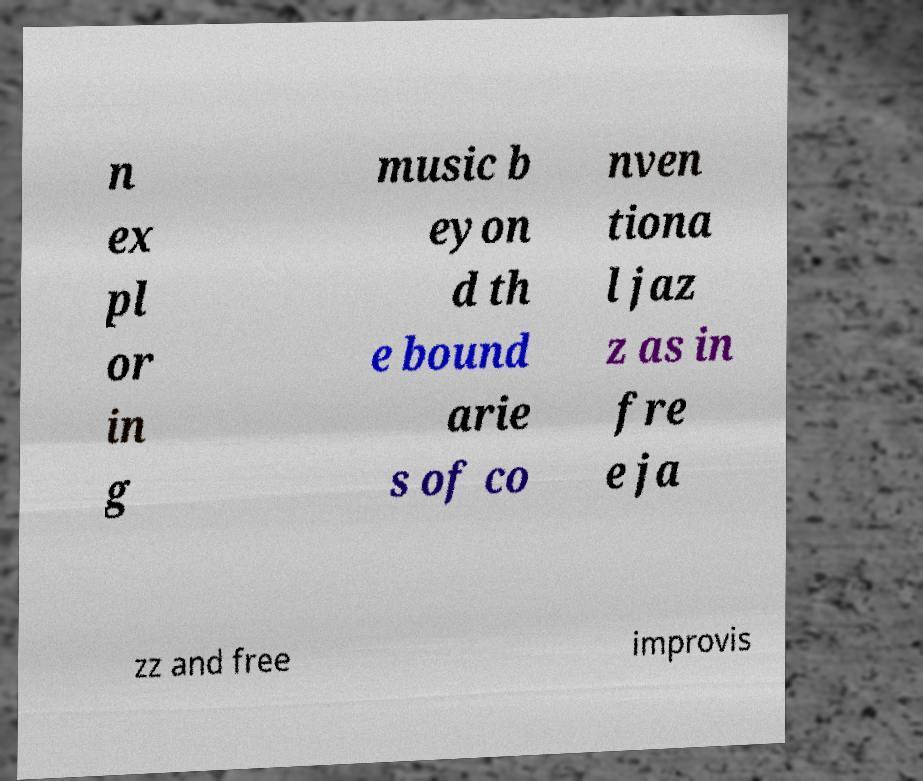Please identify and transcribe the text found in this image. n ex pl or in g music b eyon d th e bound arie s of co nven tiona l jaz z as in fre e ja zz and free improvis 